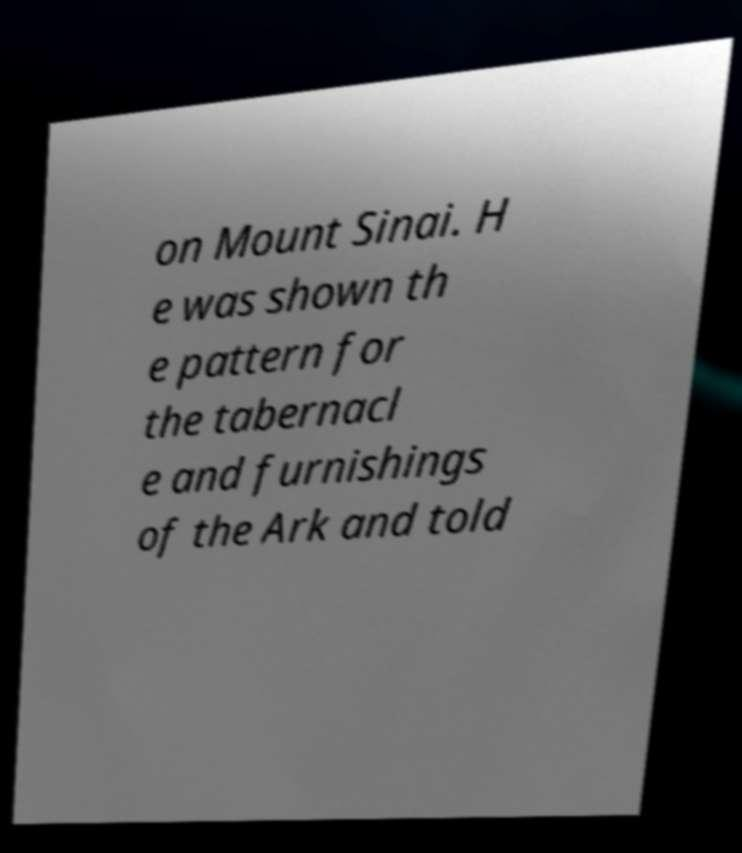What messages or text are displayed in this image? I need them in a readable, typed format. on Mount Sinai. H e was shown th e pattern for the tabernacl e and furnishings of the Ark and told 